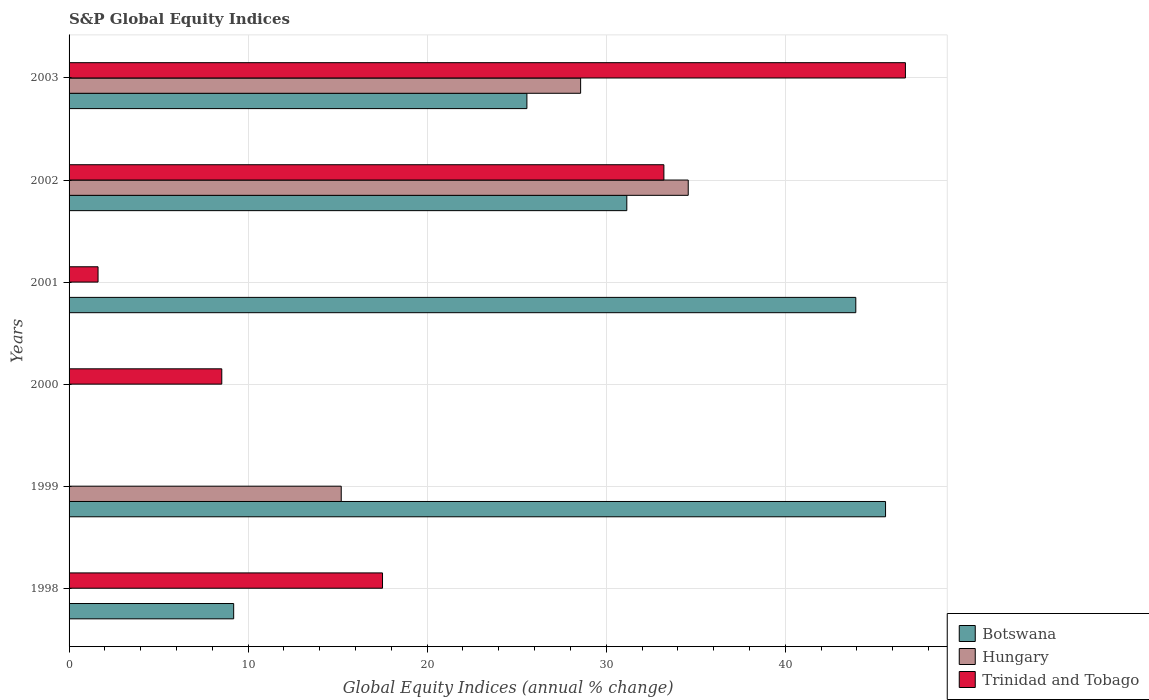How many bars are there on the 6th tick from the top?
Your response must be concise. 2. Across all years, what is the maximum global equity indices in Hungary?
Offer a terse response. 34.58. In which year was the global equity indices in Hungary maximum?
Provide a succinct answer. 2002. What is the total global equity indices in Hungary in the graph?
Offer a terse response. 78.35. What is the difference between the global equity indices in Botswana in 2001 and that in 2002?
Offer a very short reply. 12.79. What is the difference between the global equity indices in Trinidad and Tobago in 2000 and the global equity indices in Botswana in 1998?
Give a very brief answer. -0.66. What is the average global equity indices in Trinidad and Tobago per year?
Make the answer very short. 17.93. In the year 2003, what is the difference between the global equity indices in Botswana and global equity indices in Trinidad and Tobago?
Your response must be concise. -21.14. In how many years, is the global equity indices in Trinidad and Tobago greater than 38 %?
Offer a terse response. 1. What is the ratio of the global equity indices in Trinidad and Tobago in 2000 to that in 2003?
Offer a very short reply. 0.18. Is the global equity indices in Trinidad and Tobago in 2000 less than that in 2003?
Give a very brief answer. Yes. What is the difference between the highest and the second highest global equity indices in Hungary?
Give a very brief answer. 6.01. What is the difference between the highest and the lowest global equity indices in Trinidad and Tobago?
Give a very brief answer. 46.71. In how many years, is the global equity indices in Trinidad and Tobago greater than the average global equity indices in Trinidad and Tobago taken over all years?
Provide a succinct answer. 2. Are all the bars in the graph horizontal?
Ensure brevity in your answer.  Yes. Where does the legend appear in the graph?
Provide a succinct answer. Bottom right. What is the title of the graph?
Offer a terse response. S&P Global Equity Indices. What is the label or title of the X-axis?
Provide a succinct answer. Global Equity Indices (annual % change). What is the label or title of the Y-axis?
Your response must be concise. Years. What is the Global Equity Indices (annual % change) of Botswana in 1998?
Give a very brief answer. 9.19. What is the Global Equity Indices (annual % change) of Hungary in 1998?
Offer a very short reply. 0. What is the Global Equity Indices (annual % change) of Trinidad and Tobago in 1998?
Make the answer very short. 17.51. What is the Global Equity Indices (annual % change) of Botswana in 1999?
Provide a short and direct response. 45.6. What is the Global Equity Indices (annual % change) in Hungary in 1999?
Your response must be concise. 15.2. What is the Global Equity Indices (annual % change) in Trinidad and Tobago in 1999?
Make the answer very short. 0. What is the Global Equity Indices (annual % change) of Botswana in 2000?
Offer a very short reply. 0. What is the Global Equity Indices (annual % change) in Hungary in 2000?
Keep it short and to the point. 0. What is the Global Equity Indices (annual % change) in Trinidad and Tobago in 2000?
Give a very brief answer. 8.53. What is the Global Equity Indices (annual % change) of Botswana in 2001?
Your answer should be very brief. 43.94. What is the Global Equity Indices (annual % change) of Hungary in 2001?
Offer a very short reply. 0. What is the Global Equity Indices (annual % change) of Trinidad and Tobago in 2001?
Your response must be concise. 1.62. What is the Global Equity Indices (annual % change) of Botswana in 2002?
Offer a terse response. 31.15. What is the Global Equity Indices (annual % change) in Hungary in 2002?
Your response must be concise. 34.58. What is the Global Equity Indices (annual % change) of Trinidad and Tobago in 2002?
Make the answer very short. 33.22. What is the Global Equity Indices (annual % change) of Botswana in 2003?
Keep it short and to the point. 25.57. What is the Global Equity Indices (annual % change) in Hungary in 2003?
Make the answer very short. 28.57. What is the Global Equity Indices (annual % change) in Trinidad and Tobago in 2003?
Offer a very short reply. 46.71. Across all years, what is the maximum Global Equity Indices (annual % change) of Botswana?
Provide a succinct answer. 45.6. Across all years, what is the maximum Global Equity Indices (annual % change) of Hungary?
Keep it short and to the point. 34.58. Across all years, what is the maximum Global Equity Indices (annual % change) in Trinidad and Tobago?
Provide a short and direct response. 46.71. Across all years, what is the minimum Global Equity Indices (annual % change) of Botswana?
Offer a very short reply. 0. What is the total Global Equity Indices (annual % change) of Botswana in the graph?
Your answer should be very brief. 155.45. What is the total Global Equity Indices (annual % change) in Hungary in the graph?
Give a very brief answer. 78.35. What is the total Global Equity Indices (annual % change) of Trinidad and Tobago in the graph?
Provide a succinct answer. 107.58. What is the difference between the Global Equity Indices (annual % change) of Botswana in 1998 and that in 1999?
Your answer should be compact. -36.41. What is the difference between the Global Equity Indices (annual % change) of Trinidad and Tobago in 1998 and that in 2000?
Your answer should be compact. 8.98. What is the difference between the Global Equity Indices (annual % change) of Botswana in 1998 and that in 2001?
Your response must be concise. -34.75. What is the difference between the Global Equity Indices (annual % change) in Trinidad and Tobago in 1998 and that in 2001?
Offer a terse response. 15.89. What is the difference between the Global Equity Indices (annual % change) in Botswana in 1998 and that in 2002?
Give a very brief answer. -21.96. What is the difference between the Global Equity Indices (annual % change) in Trinidad and Tobago in 1998 and that in 2002?
Your answer should be very brief. -15.71. What is the difference between the Global Equity Indices (annual % change) in Botswana in 1998 and that in 2003?
Ensure brevity in your answer.  -16.38. What is the difference between the Global Equity Indices (annual % change) of Trinidad and Tobago in 1998 and that in 2003?
Ensure brevity in your answer.  -29.2. What is the difference between the Global Equity Indices (annual % change) in Botswana in 1999 and that in 2001?
Your answer should be compact. 1.66. What is the difference between the Global Equity Indices (annual % change) of Botswana in 1999 and that in 2002?
Keep it short and to the point. 14.45. What is the difference between the Global Equity Indices (annual % change) of Hungary in 1999 and that in 2002?
Offer a terse response. -19.38. What is the difference between the Global Equity Indices (annual % change) in Botswana in 1999 and that in 2003?
Provide a succinct answer. 20.03. What is the difference between the Global Equity Indices (annual % change) in Hungary in 1999 and that in 2003?
Your response must be concise. -13.37. What is the difference between the Global Equity Indices (annual % change) in Trinidad and Tobago in 2000 and that in 2001?
Ensure brevity in your answer.  6.91. What is the difference between the Global Equity Indices (annual % change) in Trinidad and Tobago in 2000 and that in 2002?
Offer a very short reply. -24.69. What is the difference between the Global Equity Indices (annual % change) in Trinidad and Tobago in 2000 and that in 2003?
Give a very brief answer. -38.18. What is the difference between the Global Equity Indices (annual % change) of Botswana in 2001 and that in 2002?
Your answer should be compact. 12.79. What is the difference between the Global Equity Indices (annual % change) in Trinidad and Tobago in 2001 and that in 2002?
Give a very brief answer. -31.6. What is the difference between the Global Equity Indices (annual % change) in Botswana in 2001 and that in 2003?
Provide a short and direct response. 18.37. What is the difference between the Global Equity Indices (annual % change) of Trinidad and Tobago in 2001 and that in 2003?
Ensure brevity in your answer.  -45.09. What is the difference between the Global Equity Indices (annual % change) in Botswana in 2002 and that in 2003?
Offer a very short reply. 5.58. What is the difference between the Global Equity Indices (annual % change) of Hungary in 2002 and that in 2003?
Make the answer very short. 6.01. What is the difference between the Global Equity Indices (annual % change) in Trinidad and Tobago in 2002 and that in 2003?
Keep it short and to the point. -13.49. What is the difference between the Global Equity Indices (annual % change) in Botswana in 1998 and the Global Equity Indices (annual % change) in Hungary in 1999?
Your answer should be compact. -6.01. What is the difference between the Global Equity Indices (annual % change) in Botswana in 1998 and the Global Equity Indices (annual % change) in Trinidad and Tobago in 2000?
Ensure brevity in your answer.  0.66. What is the difference between the Global Equity Indices (annual % change) in Botswana in 1998 and the Global Equity Indices (annual % change) in Trinidad and Tobago in 2001?
Provide a short and direct response. 7.57. What is the difference between the Global Equity Indices (annual % change) in Botswana in 1998 and the Global Equity Indices (annual % change) in Hungary in 2002?
Make the answer very short. -25.39. What is the difference between the Global Equity Indices (annual % change) in Botswana in 1998 and the Global Equity Indices (annual % change) in Trinidad and Tobago in 2002?
Give a very brief answer. -24.03. What is the difference between the Global Equity Indices (annual % change) of Botswana in 1998 and the Global Equity Indices (annual % change) of Hungary in 2003?
Your answer should be very brief. -19.38. What is the difference between the Global Equity Indices (annual % change) of Botswana in 1998 and the Global Equity Indices (annual % change) of Trinidad and Tobago in 2003?
Make the answer very short. -37.52. What is the difference between the Global Equity Indices (annual % change) in Botswana in 1999 and the Global Equity Indices (annual % change) in Trinidad and Tobago in 2000?
Your answer should be very brief. 37.07. What is the difference between the Global Equity Indices (annual % change) of Hungary in 1999 and the Global Equity Indices (annual % change) of Trinidad and Tobago in 2000?
Provide a succinct answer. 6.67. What is the difference between the Global Equity Indices (annual % change) in Botswana in 1999 and the Global Equity Indices (annual % change) in Trinidad and Tobago in 2001?
Keep it short and to the point. 43.98. What is the difference between the Global Equity Indices (annual % change) in Hungary in 1999 and the Global Equity Indices (annual % change) in Trinidad and Tobago in 2001?
Keep it short and to the point. 13.58. What is the difference between the Global Equity Indices (annual % change) of Botswana in 1999 and the Global Equity Indices (annual % change) of Hungary in 2002?
Your answer should be very brief. 11.02. What is the difference between the Global Equity Indices (annual % change) in Botswana in 1999 and the Global Equity Indices (annual % change) in Trinidad and Tobago in 2002?
Offer a terse response. 12.38. What is the difference between the Global Equity Indices (annual % change) in Hungary in 1999 and the Global Equity Indices (annual % change) in Trinidad and Tobago in 2002?
Offer a terse response. -18.02. What is the difference between the Global Equity Indices (annual % change) of Botswana in 1999 and the Global Equity Indices (annual % change) of Hungary in 2003?
Make the answer very short. 17.03. What is the difference between the Global Equity Indices (annual % change) in Botswana in 1999 and the Global Equity Indices (annual % change) in Trinidad and Tobago in 2003?
Your response must be concise. -1.11. What is the difference between the Global Equity Indices (annual % change) of Hungary in 1999 and the Global Equity Indices (annual % change) of Trinidad and Tobago in 2003?
Offer a terse response. -31.51. What is the difference between the Global Equity Indices (annual % change) in Botswana in 2001 and the Global Equity Indices (annual % change) in Hungary in 2002?
Make the answer very short. 9.36. What is the difference between the Global Equity Indices (annual % change) of Botswana in 2001 and the Global Equity Indices (annual % change) of Trinidad and Tobago in 2002?
Your answer should be very brief. 10.72. What is the difference between the Global Equity Indices (annual % change) of Botswana in 2001 and the Global Equity Indices (annual % change) of Hungary in 2003?
Keep it short and to the point. 15.37. What is the difference between the Global Equity Indices (annual % change) in Botswana in 2001 and the Global Equity Indices (annual % change) in Trinidad and Tobago in 2003?
Ensure brevity in your answer.  -2.77. What is the difference between the Global Equity Indices (annual % change) in Botswana in 2002 and the Global Equity Indices (annual % change) in Hungary in 2003?
Keep it short and to the point. 2.58. What is the difference between the Global Equity Indices (annual % change) in Botswana in 2002 and the Global Equity Indices (annual % change) in Trinidad and Tobago in 2003?
Provide a succinct answer. -15.56. What is the difference between the Global Equity Indices (annual % change) in Hungary in 2002 and the Global Equity Indices (annual % change) in Trinidad and Tobago in 2003?
Keep it short and to the point. -12.13. What is the average Global Equity Indices (annual % change) of Botswana per year?
Ensure brevity in your answer.  25.91. What is the average Global Equity Indices (annual % change) of Hungary per year?
Your answer should be very brief. 13.06. What is the average Global Equity Indices (annual % change) of Trinidad and Tobago per year?
Ensure brevity in your answer.  17.93. In the year 1998, what is the difference between the Global Equity Indices (annual % change) of Botswana and Global Equity Indices (annual % change) of Trinidad and Tobago?
Make the answer very short. -8.31. In the year 1999, what is the difference between the Global Equity Indices (annual % change) in Botswana and Global Equity Indices (annual % change) in Hungary?
Make the answer very short. 30.4. In the year 2001, what is the difference between the Global Equity Indices (annual % change) in Botswana and Global Equity Indices (annual % change) in Trinidad and Tobago?
Provide a short and direct response. 42.32. In the year 2002, what is the difference between the Global Equity Indices (annual % change) of Botswana and Global Equity Indices (annual % change) of Hungary?
Your answer should be compact. -3.43. In the year 2002, what is the difference between the Global Equity Indices (annual % change) of Botswana and Global Equity Indices (annual % change) of Trinidad and Tobago?
Offer a terse response. -2.07. In the year 2002, what is the difference between the Global Equity Indices (annual % change) in Hungary and Global Equity Indices (annual % change) in Trinidad and Tobago?
Provide a succinct answer. 1.36. In the year 2003, what is the difference between the Global Equity Indices (annual % change) of Botswana and Global Equity Indices (annual % change) of Trinidad and Tobago?
Provide a short and direct response. -21.14. In the year 2003, what is the difference between the Global Equity Indices (annual % change) of Hungary and Global Equity Indices (annual % change) of Trinidad and Tobago?
Make the answer very short. -18.14. What is the ratio of the Global Equity Indices (annual % change) of Botswana in 1998 to that in 1999?
Provide a succinct answer. 0.2. What is the ratio of the Global Equity Indices (annual % change) of Trinidad and Tobago in 1998 to that in 2000?
Offer a terse response. 2.05. What is the ratio of the Global Equity Indices (annual % change) of Botswana in 1998 to that in 2001?
Keep it short and to the point. 0.21. What is the ratio of the Global Equity Indices (annual % change) of Trinidad and Tobago in 1998 to that in 2001?
Give a very brief answer. 10.82. What is the ratio of the Global Equity Indices (annual % change) of Botswana in 1998 to that in 2002?
Your answer should be very brief. 0.3. What is the ratio of the Global Equity Indices (annual % change) of Trinidad and Tobago in 1998 to that in 2002?
Your answer should be compact. 0.53. What is the ratio of the Global Equity Indices (annual % change) of Botswana in 1998 to that in 2003?
Your answer should be compact. 0.36. What is the ratio of the Global Equity Indices (annual % change) of Trinidad and Tobago in 1998 to that in 2003?
Offer a very short reply. 0.37. What is the ratio of the Global Equity Indices (annual % change) in Botswana in 1999 to that in 2001?
Provide a short and direct response. 1.04. What is the ratio of the Global Equity Indices (annual % change) in Botswana in 1999 to that in 2002?
Offer a terse response. 1.46. What is the ratio of the Global Equity Indices (annual % change) in Hungary in 1999 to that in 2002?
Give a very brief answer. 0.44. What is the ratio of the Global Equity Indices (annual % change) in Botswana in 1999 to that in 2003?
Provide a succinct answer. 1.78. What is the ratio of the Global Equity Indices (annual % change) of Hungary in 1999 to that in 2003?
Ensure brevity in your answer.  0.53. What is the ratio of the Global Equity Indices (annual % change) of Trinidad and Tobago in 2000 to that in 2001?
Keep it short and to the point. 5.27. What is the ratio of the Global Equity Indices (annual % change) of Trinidad and Tobago in 2000 to that in 2002?
Keep it short and to the point. 0.26. What is the ratio of the Global Equity Indices (annual % change) in Trinidad and Tobago in 2000 to that in 2003?
Provide a short and direct response. 0.18. What is the ratio of the Global Equity Indices (annual % change) of Botswana in 2001 to that in 2002?
Ensure brevity in your answer.  1.41. What is the ratio of the Global Equity Indices (annual % change) in Trinidad and Tobago in 2001 to that in 2002?
Provide a short and direct response. 0.05. What is the ratio of the Global Equity Indices (annual % change) in Botswana in 2001 to that in 2003?
Ensure brevity in your answer.  1.72. What is the ratio of the Global Equity Indices (annual % change) in Trinidad and Tobago in 2001 to that in 2003?
Offer a terse response. 0.03. What is the ratio of the Global Equity Indices (annual % change) in Botswana in 2002 to that in 2003?
Offer a very short reply. 1.22. What is the ratio of the Global Equity Indices (annual % change) in Hungary in 2002 to that in 2003?
Offer a terse response. 1.21. What is the ratio of the Global Equity Indices (annual % change) of Trinidad and Tobago in 2002 to that in 2003?
Provide a short and direct response. 0.71. What is the difference between the highest and the second highest Global Equity Indices (annual % change) of Botswana?
Ensure brevity in your answer.  1.66. What is the difference between the highest and the second highest Global Equity Indices (annual % change) of Hungary?
Your answer should be very brief. 6.01. What is the difference between the highest and the second highest Global Equity Indices (annual % change) in Trinidad and Tobago?
Offer a very short reply. 13.49. What is the difference between the highest and the lowest Global Equity Indices (annual % change) in Botswana?
Your answer should be compact. 45.6. What is the difference between the highest and the lowest Global Equity Indices (annual % change) in Hungary?
Your response must be concise. 34.58. What is the difference between the highest and the lowest Global Equity Indices (annual % change) of Trinidad and Tobago?
Give a very brief answer. 46.71. 